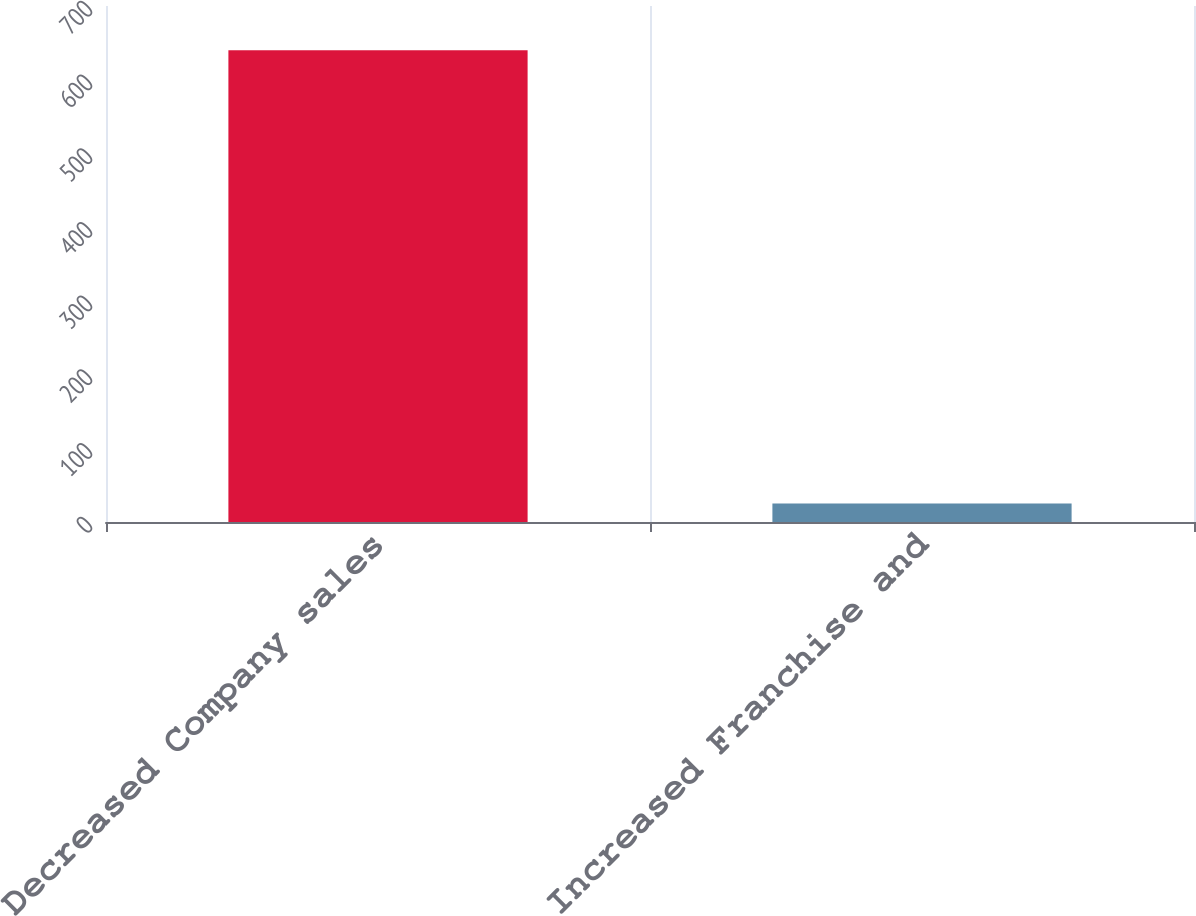Convert chart. <chart><loc_0><loc_0><loc_500><loc_500><bar_chart><fcel>Decreased Company sales<fcel>Increased Franchise and<nl><fcel>640<fcel>25<nl></chart> 